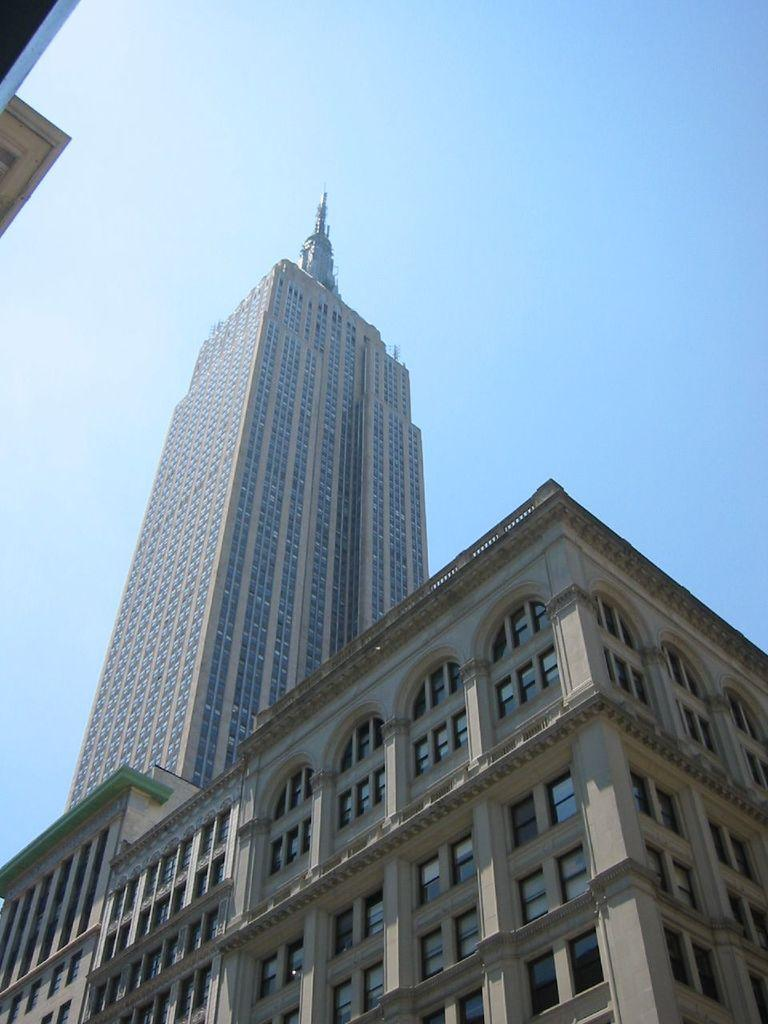What is the main subject in the center of the image? There is a building in the center of the image. What can be seen at the top of the image? The sky is visible at the top of the image. What thought is the building having in the image? Buildings do not have thoughts, as they are inanimate objects. 